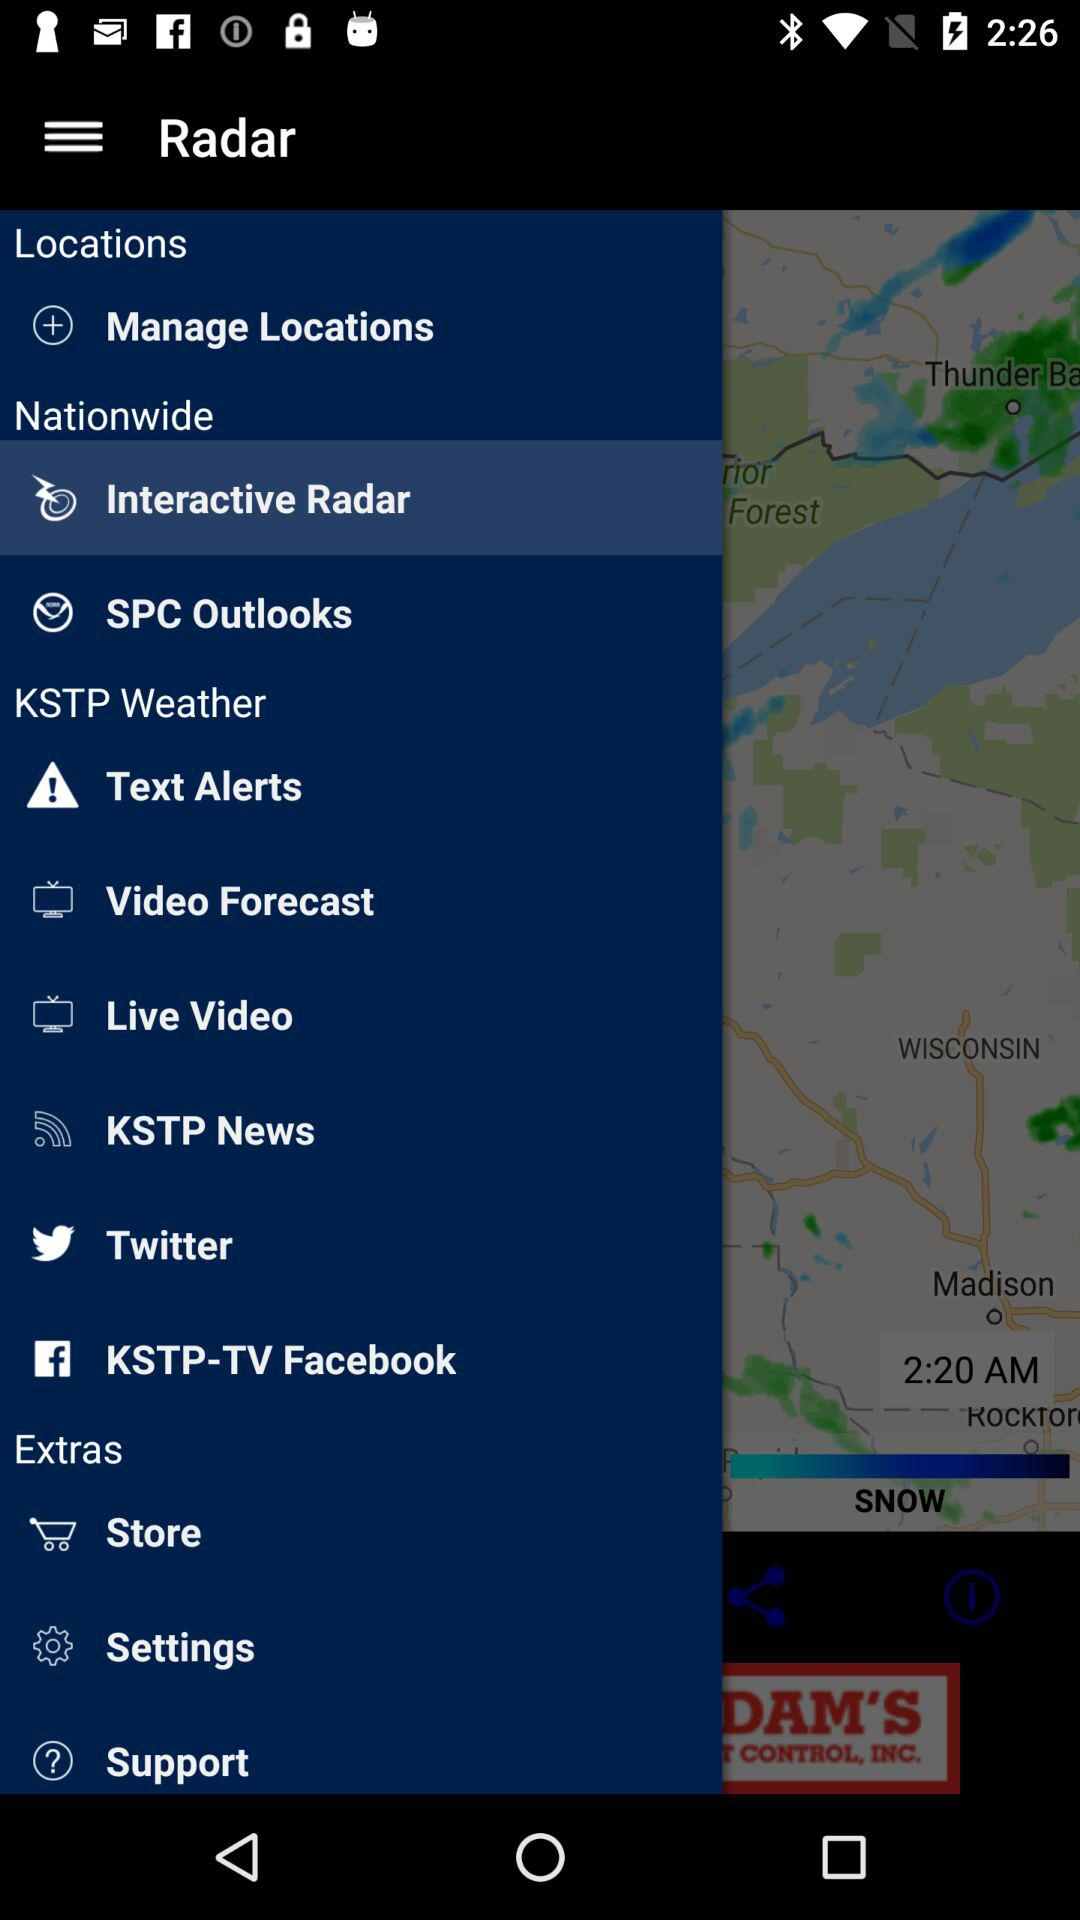What is the selected option? The selected option is "Interactive Radar". 